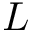<formula> <loc_0><loc_0><loc_500><loc_500>L</formula> 